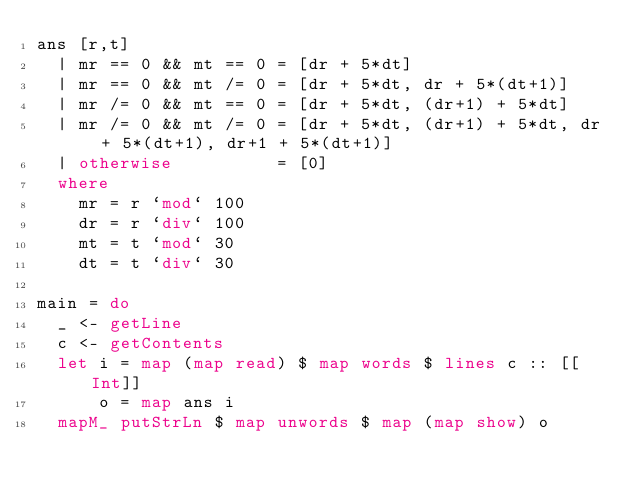<code> <loc_0><loc_0><loc_500><loc_500><_Haskell_>ans [r,t] 
  | mr == 0 && mt == 0 = [dr + 5*dt]
  | mr == 0 && mt /= 0 = [dr + 5*dt, dr + 5*(dt+1)]
  | mr /= 0 && mt == 0 = [dr + 5*dt, (dr+1) + 5*dt]
  | mr /= 0 && mt /= 0 = [dr + 5*dt, (dr+1) + 5*dt, dr + 5*(dt+1), dr+1 + 5*(dt+1)]
  | otherwise          = [0]
  where
    mr = r `mod` 100
    dr = r `div` 100
    mt = t `mod` 30
    dt = t `div` 30
        
main = do
  _ <- getLine
  c <- getContents
  let i = map (map read) $ map words $ lines c :: [[Int]]
      o = map ans i
  mapM_ putStrLn $ map unwords $ map (map show) o</code> 